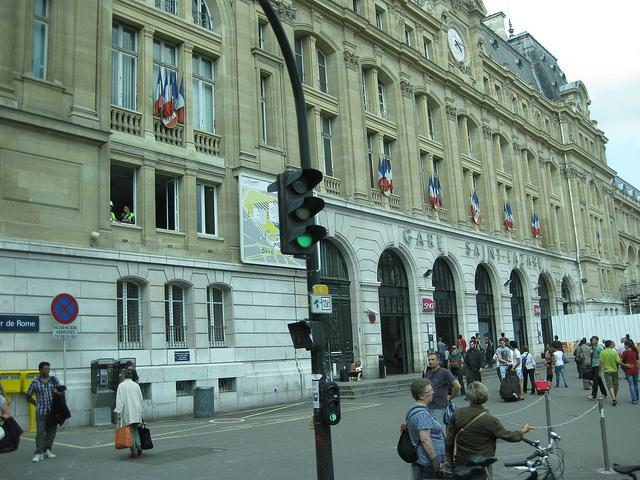What country's flag is being flown?

Choices:
A) france
B) italy
C) switzerland
D) england france 